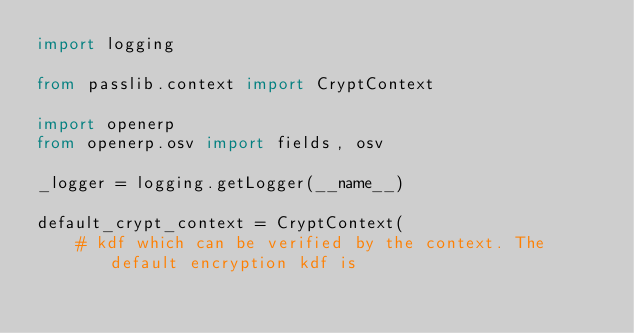Convert code to text. <code><loc_0><loc_0><loc_500><loc_500><_Python_>import logging

from passlib.context import CryptContext

import openerp
from openerp.osv import fields, osv

_logger = logging.getLogger(__name__)

default_crypt_context = CryptContext(
    # kdf which can be verified by the context. The default encryption kdf is</code> 